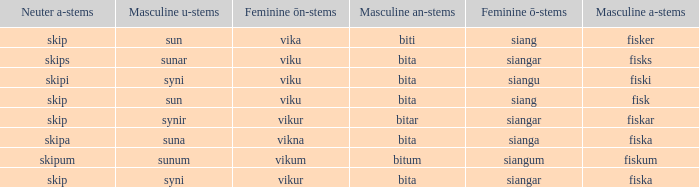What ending does siangu get for ön? Viku. 